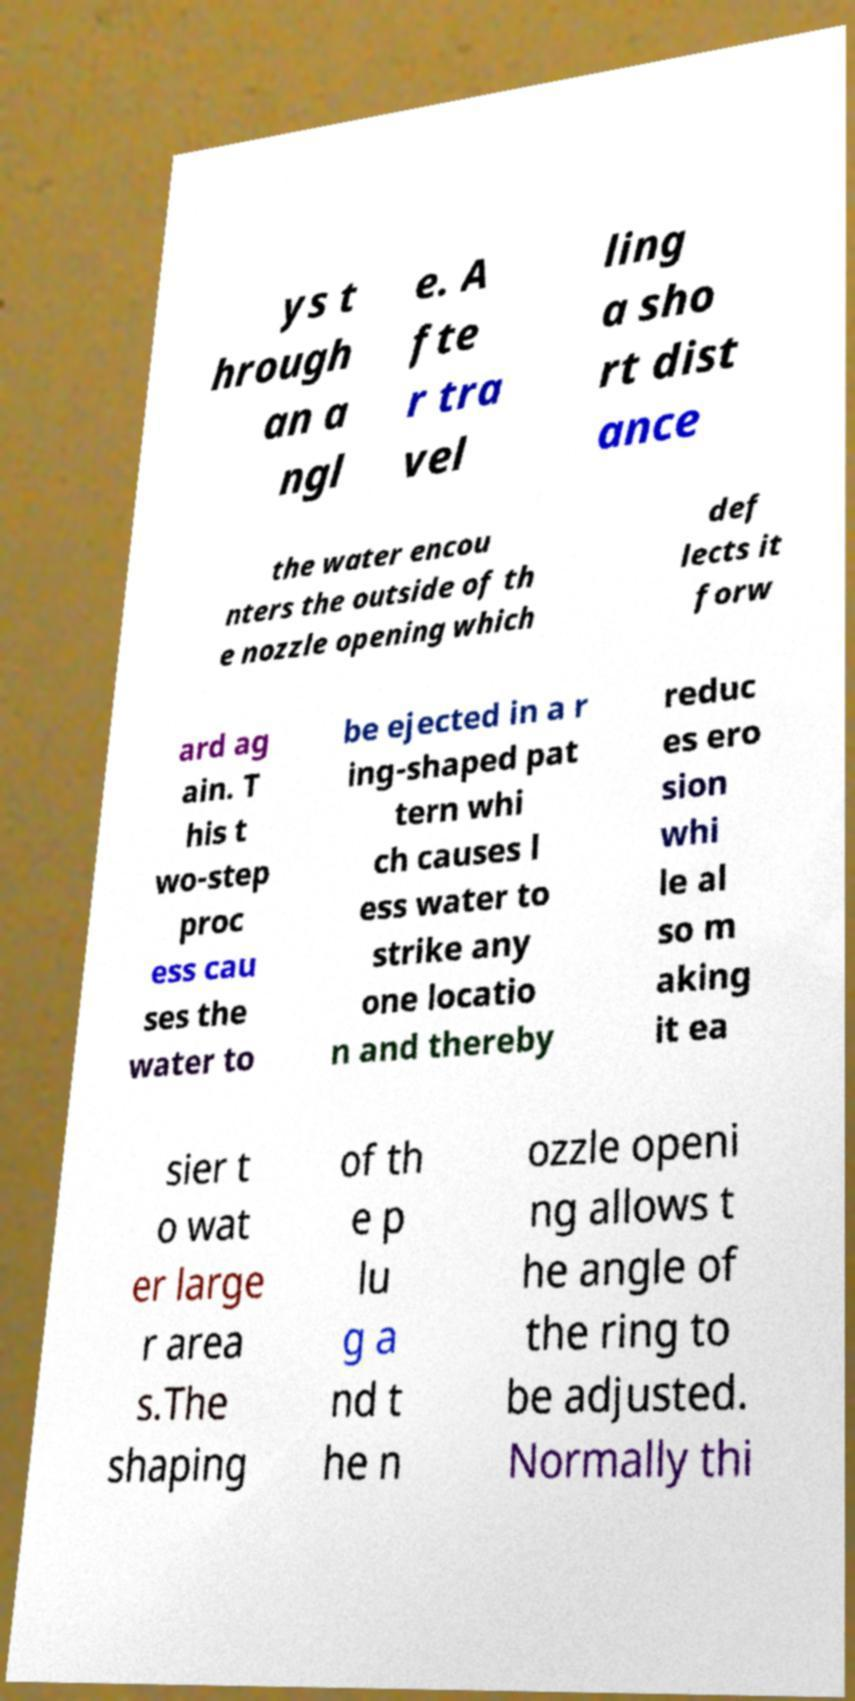What messages or text are displayed in this image? I need them in a readable, typed format. ys t hrough an a ngl e. A fte r tra vel ling a sho rt dist ance the water encou nters the outside of th e nozzle opening which def lects it forw ard ag ain. T his t wo-step proc ess cau ses the water to be ejected in a r ing-shaped pat tern whi ch causes l ess water to strike any one locatio n and thereby reduc es ero sion whi le al so m aking it ea sier t o wat er large r area s.The shaping of th e p lu g a nd t he n ozzle openi ng allows t he angle of the ring to be adjusted. Normally thi 